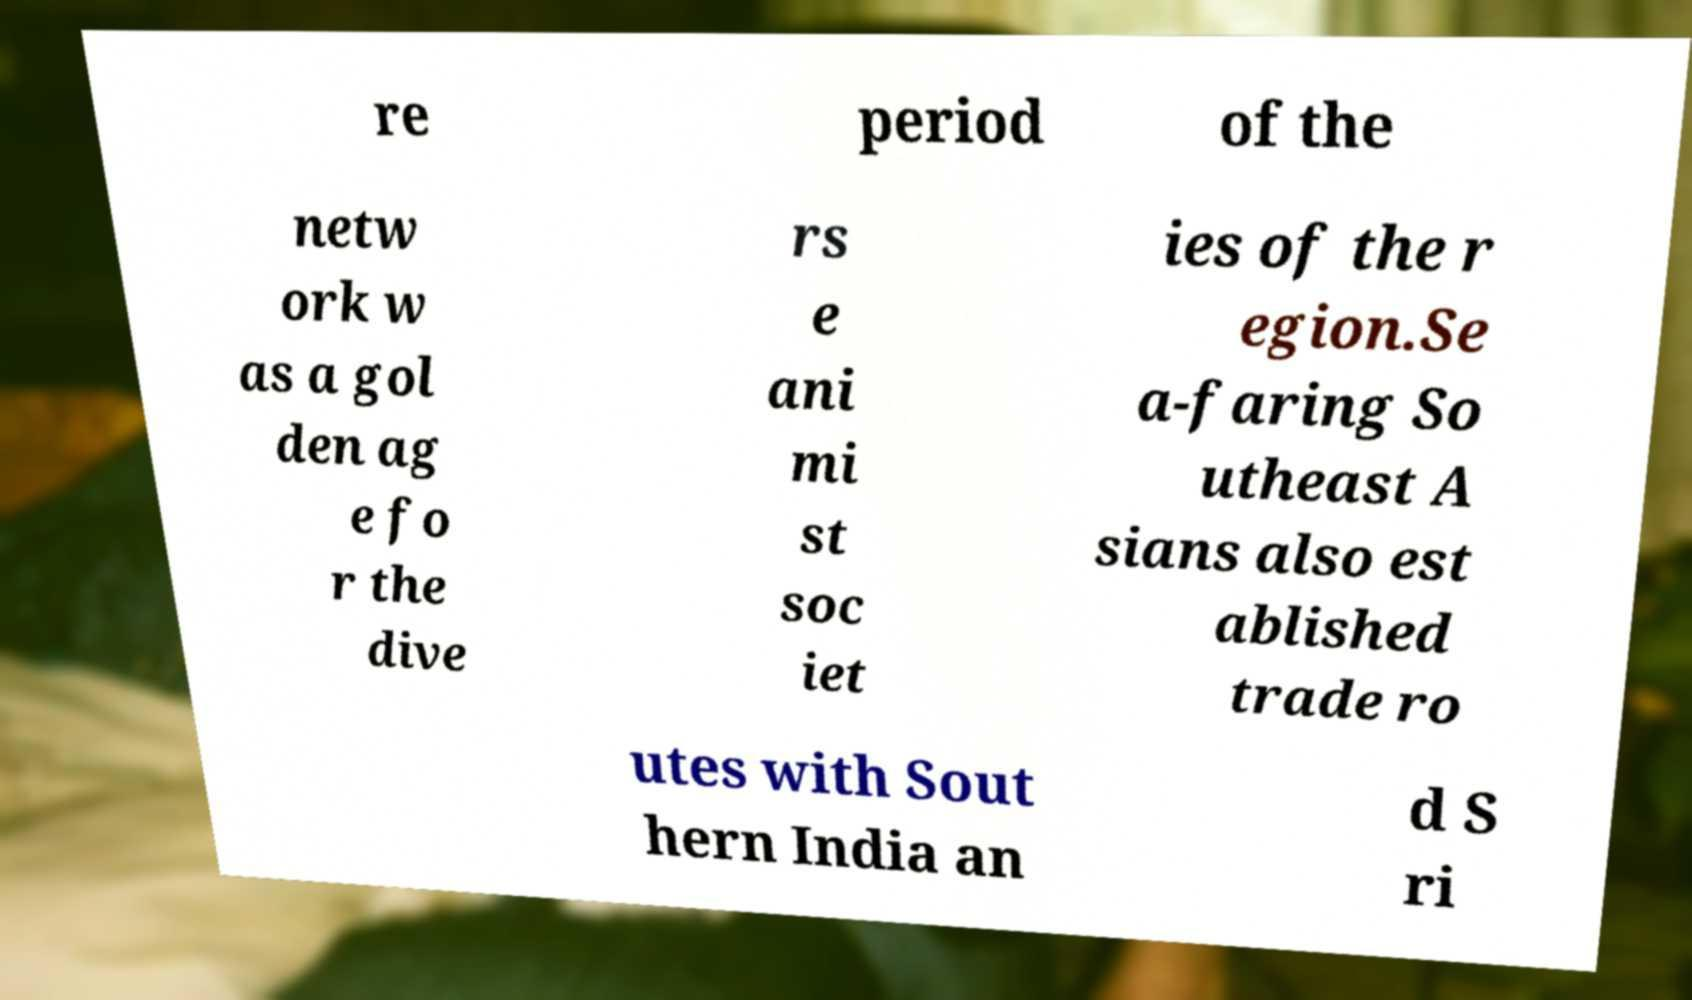Could you assist in decoding the text presented in this image and type it out clearly? re period of the netw ork w as a gol den ag e fo r the dive rs e ani mi st soc iet ies of the r egion.Se a-faring So utheast A sians also est ablished trade ro utes with Sout hern India an d S ri 